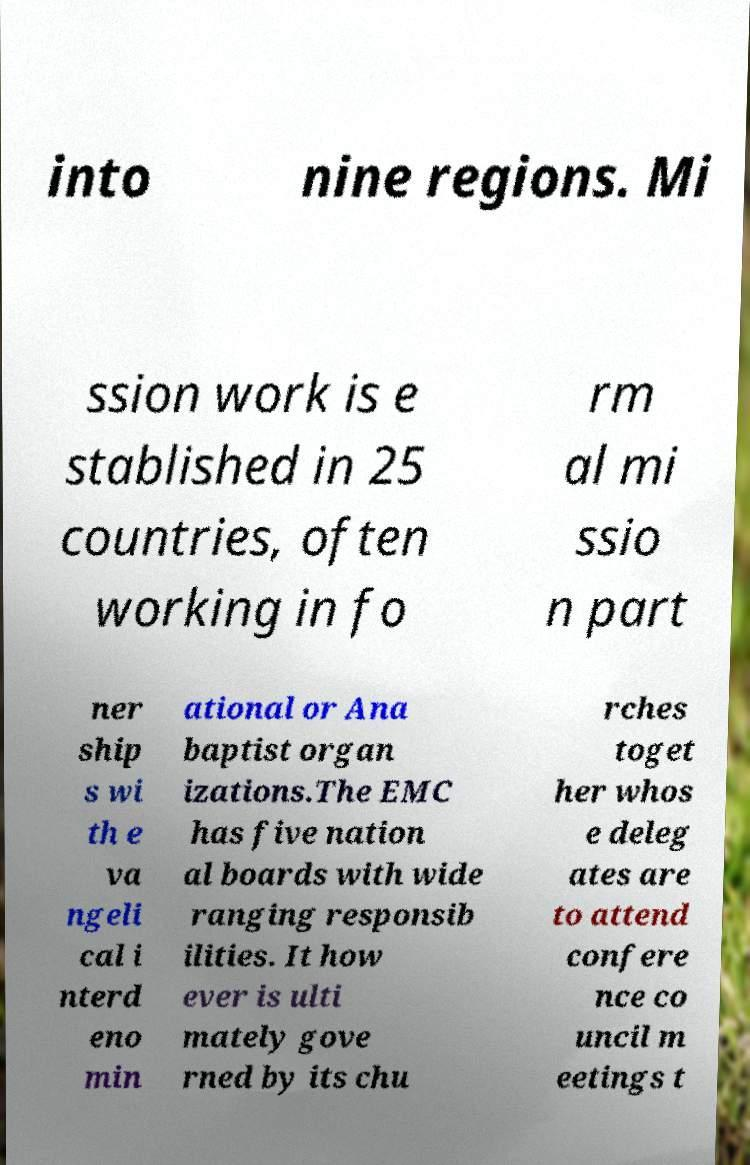Please identify and transcribe the text found in this image. into nine regions. Mi ssion work is e stablished in 25 countries, often working in fo rm al mi ssio n part ner ship s wi th e va ngeli cal i nterd eno min ational or Ana baptist organ izations.The EMC has five nation al boards with wide ranging responsib ilities. It how ever is ulti mately gove rned by its chu rches toget her whos e deleg ates are to attend confere nce co uncil m eetings t 